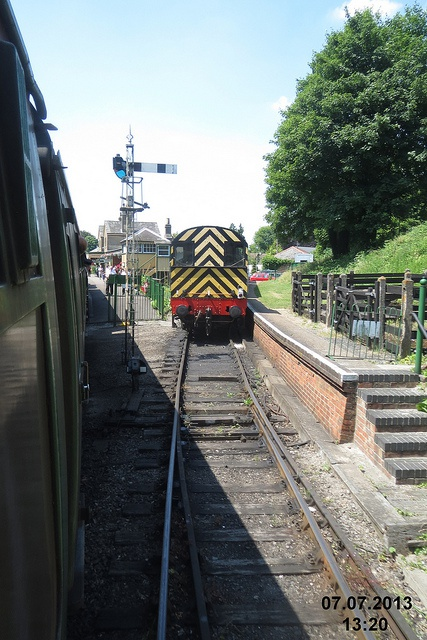Describe the objects in this image and their specific colors. I can see train in black, gray, blue, and navy tones and train in black, gray, tan, and maroon tones in this image. 